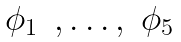<formula> <loc_0><loc_0><loc_500><loc_500>\begin{matrix} \phi _ { 1 } & , \dots , & \phi _ { 5 } \\ \end{matrix}</formula> 